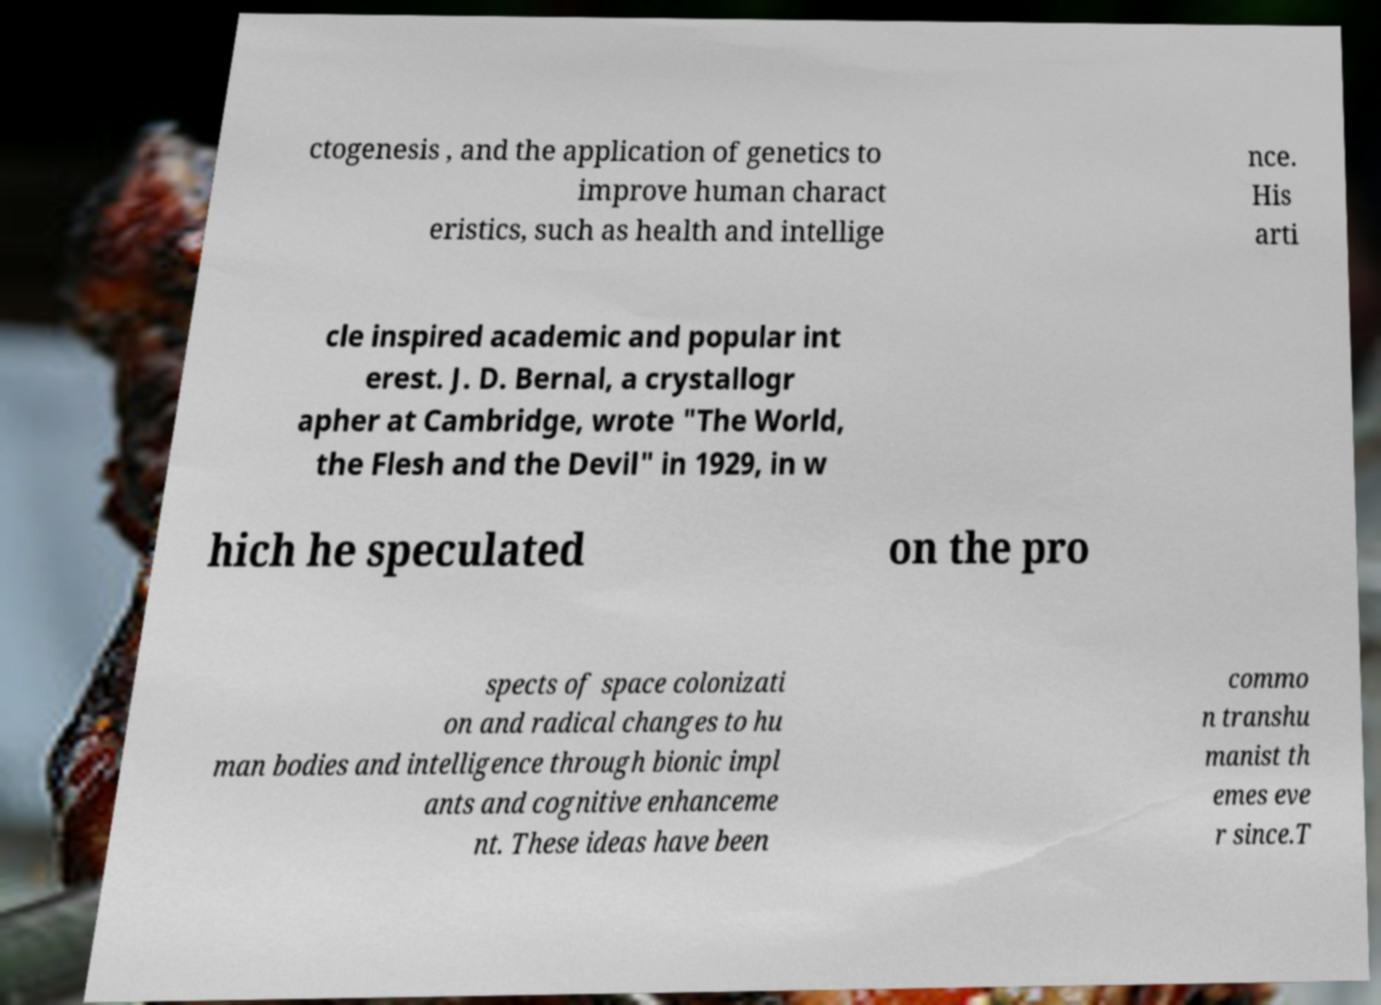Could you extract and type out the text from this image? ctogenesis , and the application of genetics to improve human charact eristics, such as health and intellige nce. His arti cle inspired academic and popular int erest. J. D. Bernal, a crystallogr apher at Cambridge, wrote "The World, the Flesh and the Devil" in 1929, in w hich he speculated on the pro spects of space colonizati on and radical changes to hu man bodies and intelligence through bionic impl ants and cognitive enhanceme nt. These ideas have been commo n transhu manist th emes eve r since.T 